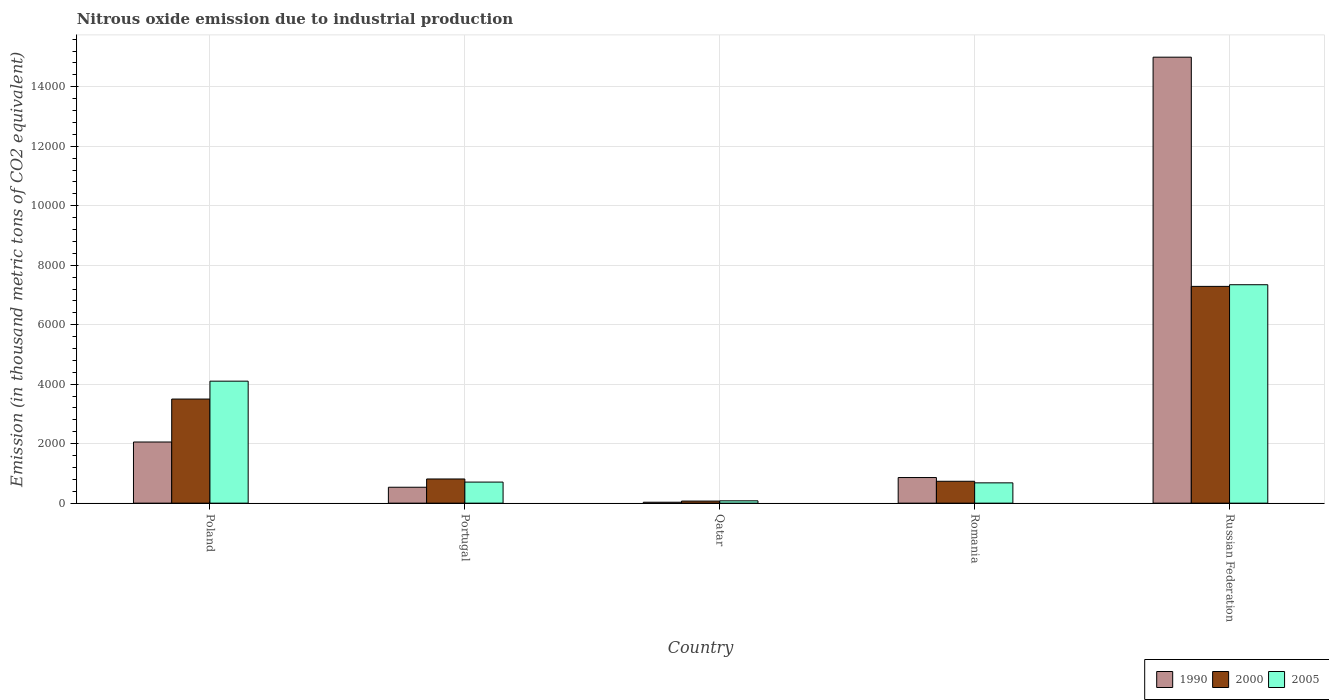How many different coloured bars are there?
Your answer should be very brief. 3. How many groups of bars are there?
Offer a very short reply. 5. How many bars are there on the 2nd tick from the left?
Make the answer very short. 3. What is the label of the 1st group of bars from the left?
Your answer should be very brief. Poland. In how many cases, is the number of bars for a given country not equal to the number of legend labels?
Your response must be concise. 0. What is the amount of nitrous oxide emitted in 1990 in Romania?
Give a very brief answer. 861.1. Across all countries, what is the maximum amount of nitrous oxide emitted in 1990?
Offer a terse response. 1.50e+04. Across all countries, what is the minimum amount of nitrous oxide emitted in 2000?
Provide a succinct answer. 69.5. In which country was the amount of nitrous oxide emitted in 2005 maximum?
Offer a terse response. Russian Federation. In which country was the amount of nitrous oxide emitted in 2005 minimum?
Ensure brevity in your answer.  Qatar. What is the total amount of nitrous oxide emitted in 1990 in the graph?
Make the answer very short. 1.85e+04. What is the difference between the amount of nitrous oxide emitted in 1990 in Portugal and that in Russian Federation?
Keep it short and to the point. -1.45e+04. What is the difference between the amount of nitrous oxide emitted in 2005 in Russian Federation and the amount of nitrous oxide emitted in 1990 in Qatar?
Provide a succinct answer. 7313.3. What is the average amount of nitrous oxide emitted in 2005 per country?
Give a very brief answer. 2582.82. What is the difference between the amount of nitrous oxide emitted of/in 1990 and amount of nitrous oxide emitted of/in 2000 in Romania?
Your answer should be compact. 125.8. What is the ratio of the amount of nitrous oxide emitted in 2000 in Romania to that in Russian Federation?
Your answer should be compact. 0.1. Is the amount of nitrous oxide emitted in 2000 in Romania less than that in Russian Federation?
Keep it short and to the point. Yes. Is the difference between the amount of nitrous oxide emitted in 1990 in Portugal and Romania greater than the difference between the amount of nitrous oxide emitted in 2000 in Portugal and Romania?
Provide a succinct answer. No. What is the difference between the highest and the second highest amount of nitrous oxide emitted in 2005?
Your response must be concise. 6636.1. What is the difference between the highest and the lowest amount of nitrous oxide emitted in 2000?
Your response must be concise. 7218.9. In how many countries, is the amount of nitrous oxide emitted in 1990 greater than the average amount of nitrous oxide emitted in 1990 taken over all countries?
Your answer should be compact. 1. Is the sum of the amount of nitrous oxide emitted in 2005 in Qatar and Russian Federation greater than the maximum amount of nitrous oxide emitted in 2000 across all countries?
Your answer should be compact. Yes. What does the 1st bar from the right in Qatar represents?
Provide a short and direct response. 2005. Is it the case that in every country, the sum of the amount of nitrous oxide emitted in 1990 and amount of nitrous oxide emitted in 2005 is greater than the amount of nitrous oxide emitted in 2000?
Ensure brevity in your answer.  Yes. How many bars are there?
Make the answer very short. 15. How many countries are there in the graph?
Provide a short and direct response. 5. Are the values on the major ticks of Y-axis written in scientific E-notation?
Provide a succinct answer. No. Does the graph contain any zero values?
Give a very brief answer. No. Where does the legend appear in the graph?
Ensure brevity in your answer.  Bottom right. How many legend labels are there?
Your response must be concise. 3. What is the title of the graph?
Offer a terse response. Nitrous oxide emission due to industrial production. What is the label or title of the X-axis?
Keep it short and to the point. Country. What is the label or title of the Y-axis?
Provide a short and direct response. Emission (in thousand metric tons of CO2 equivalent). What is the Emission (in thousand metric tons of CO2 equivalent) in 1990 in Poland?
Your answer should be compact. 2055.6. What is the Emission (in thousand metric tons of CO2 equivalent) in 2000 in Poland?
Your answer should be compact. 3499.7. What is the Emission (in thousand metric tons of CO2 equivalent) of 2005 in Poland?
Ensure brevity in your answer.  4101.5. What is the Emission (in thousand metric tons of CO2 equivalent) in 1990 in Portugal?
Ensure brevity in your answer.  534.9. What is the Emission (in thousand metric tons of CO2 equivalent) in 2000 in Portugal?
Provide a succinct answer. 812.7. What is the Emission (in thousand metric tons of CO2 equivalent) in 2005 in Portugal?
Make the answer very short. 708. What is the Emission (in thousand metric tons of CO2 equivalent) of 1990 in Qatar?
Give a very brief answer. 30.8. What is the Emission (in thousand metric tons of CO2 equivalent) in 2000 in Qatar?
Provide a short and direct response. 69.5. What is the Emission (in thousand metric tons of CO2 equivalent) in 2005 in Qatar?
Offer a very short reply. 78.2. What is the Emission (in thousand metric tons of CO2 equivalent) of 1990 in Romania?
Keep it short and to the point. 861.1. What is the Emission (in thousand metric tons of CO2 equivalent) of 2000 in Romania?
Ensure brevity in your answer.  735.3. What is the Emission (in thousand metric tons of CO2 equivalent) in 2005 in Romania?
Offer a very short reply. 682.3. What is the Emission (in thousand metric tons of CO2 equivalent) of 1990 in Russian Federation?
Offer a terse response. 1.50e+04. What is the Emission (in thousand metric tons of CO2 equivalent) in 2000 in Russian Federation?
Provide a short and direct response. 7288.4. What is the Emission (in thousand metric tons of CO2 equivalent) in 2005 in Russian Federation?
Your answer should be compact. 7344.1. Across all countries, what is the maximum Emission (in thousand metric tons of CO2 equivalent) in 1990?
Offer a terse response. 1.50e+04. Across all countries, what is the maximum Emission (in thousand metric tons of CO2 equivalent) of 2000?
Your answer should be very brief. 7288.4. Across all countries, what is the maximum Emission (in thousand metric tons of CO2 equivalent) in 2005?
Ensure brevity in your answer.  7344.1. Across all countries, what is the minimum Emission (in thousand metric tons of CO2 equivalent) in 1990?
Provide a short and direct response. 30.8. Across all countries, what is the minimum Emission (in thousand metric tons of CO2 equivalent) in 2000?
Your answer should be very brief. 69.5. Across all countries, what is the minimum Emission (in thousand metric tons of CO2 equivalent) in 2005?
Your answer should be very brief. 78.2. What is the total Emission (in thousand metric tons of CO2 equivalent) of 1990 in the graph?
Ensure brevity in your answer.  1.85e+04. What is the total Emission (in thousand metric tons of CO2 equivalent) in 2000 in the graph?
Provide a short and direct response. 1.24e+04. What is the total Emission (in thousand metric tons of CO2 equivalent) of 2005 in the graph?
Make the answer very short. 1.29e+04. What is the difference between the Emission (in thousand metric tons of CO2 equivalent) in 1990 in Poland and that in Portugal?
Offer a very short reply. 1520.7. What is the difference between the Emission (in thousand metric tons of CO2 equivalent) in 2000 in Poland and that in Portugal?
Keep it short and to the point. 2687. What is the difference between the Emission (in thousand metric tons of CO2 equivalent) in 2005 in Poland and that in Portugal?
Ensure brevity in your answer.  3393.5. What is the difference between the Emission (in thousand metric tons of CO2 equivalent) in 1990 in Poland and that in Qatar?
Make the answer very short. 2024.8. What is the difference between the Emission (in thousand metric tons of CO2 equivalent) of 2000 in Poland and that in Qatar?
Make the answer very short. 3430.2. What is the difference between the Emission (in thousand metric tons of CO2 equivalent) in 2005 in Poland and that in Qatar?
Offer a very short reply. 4023.3. What is the difference between the Emission (in thousand metric tons of CO2 equivalent) of 1990 in Poland and that in Romania?
Your response must be concise. 1194.5. What is the difference between the Emission (in thousand metric tons of CO2 equivalent) in 2000 in Poland and that in Romania?
Your response must be concise. 2764.4. What is the difference between the Emission (in thousand metric tons of CO2 equivalent) of 2005 in Poland and that in Romania?
Your answer should be very brief. 3419.2. What is the difference between the Emission (in thousand metric tons of CO2 equivalent) of 1990 in Poland and that in Russian Federation?
Your answer should be very brief. -1.29e+04. What is the difference between the Emission (in thousand metric tons of CO2 equivalent) of 2000 in Poland and that in Russian Federation?
Offer a terse response. -3788.7. What is the difference between the Emission (in thousand metric tons of CO2 equivalent) of 2005 in Poland and that in Russian Federation?
Offer a very short reply. -3242.6. What is the difference between the Emission (in thousand metric tons of CO2 equivalent) of 1990 in Portugal and that in Qatar?
Offer a very short reply. 504.1. What is the difference between the Emission (in thousand metric tons of CO2 equivalent) of 2000 in Portugal and that in Qatar?
Your response must be concise. 743.2. What is the difference between the Emission (in thousand metric tons of CO2 equivalent) in 2005 in Portugal and that in Qatar?
Offer a very short reply. 629.8. What is the difference between the Emission (in thousand metric tons of CO2 equivalent) in 1990 in Portugal and that in Romania?
Give a very brief answer. -326.2. What is the difference between the Emission (in thousand metric tons of CO2 equivalent) of 2000 in Portugal and that in Romania?
Offer a terse response. 77.4. What is the difference between the Emission (in thousand metric tons of CO2 equivalent) in 2005 in Portugal and that in Romania?
Offer a terse response. 25.7. What is the difference between the Emission (in thousand metric tons of CO2 equivalent) of 1990 in Portugal and that in Russian Federation?
Offer a terse response. -1.45e+04. What is the difference between the Emission (in thousand metric tons of CO2 equivalent) in 2000 in Portugal and that in Russian Federation?
Give a very brief answer. -6475.7. What is the difference between the Emission (in thousand metric tons of CO2 equivalent) in 2005 in Portugal and that in Russian Federation?
Your answer should be compact. -6636.1. What is the difference between the Emission (in thousand metric tons of CO2 equivalent) in 1990 in Qatar and that in Romania?
Give a very brief answer. -830.3. What is the difference between the Emission (in thousand metric tons of CO2 equivalent) in 2000 in Qatar and that in Romania?
Offer a very short reply. -665.8. What is the difference between the Emission (in thousand metric tons of CO2 equivalent) of 2005 in Qatar and that in Romania?
Your answer should be compact. -604.1. What is the difference between the Emission (in thousand metric tons of CO2 equivalent) in 1990 in Qatar and that in Russian Federation?
Keep it short and to the point. -1.50e+04. What is the difference between the Emission (in thousand metric tons of CO2 equivalent) in 2000 in Qatar and that in Russian Federation?
Give a very brief answer. -7218.9. What is the difference between the Emission (in thousand metric tons of CO2 equivalent) of 2005 in Qatar and that in Russian Federation?
Your answer should be compact. -7265.9. What is the difference between the Emission (in thousand metric tons of CO2 equivalent) of 1990 in Romania and that in Russian Federation?
Offer a terse response. -1.41e+04. What is the difference between the Emission (in thousand metric tons of CO2 equivalent) in 2000 in Romania and that in Russian Federation?
Provide a short and direct response. -6553.1. What is the difference between the Emission (in thousand metric tons of CO2 equivalent) in 2005 in Romania and that in Russian Federation?
Give a very brief answer. -6661.8. What is the difference between the Emission (in thousand metric tons of CO2 equivalent) of 1990 in Poland and the Emission (in thousand metric tons of CO2 equivalent) of 2000 in Portugal?
Your response must be concise. 1242.9. What is the difference between the Emission (in thousand metric tons of CO2 equivalent) of 1990 in Poland and the Emission (in thousand metric tons of CO2 equivalent) of 2005 in Portugal?
Give a very brief answer. 1347.6. What is the difference between the Emission (in thousand metric tons of CO2 equivalent) in 2000 in Poland and the Emission (in thousand metric tons of CO2 equivalent) in 2005 in Portugal?
Your answer should be compact. 2791.7. What is the difference between the Emission (in thousand metric tons of CO2 equivalent) in 1990 in Poland and the Emission (in thousand metric tons of CO2 equivalent) in 2000 in Qatar?
Give a very brief answer. 1986.1. What is the difference between the Emission (in thousand metric tons of CO2 equivalent) of 1990 in Poland and the Emission (in thousand metric tons of CO2 equivalent) of 2005 in Qatar?
Give a very brief answer. 1977.4. What is the difference between the Emission (in thousand metric tons of CO2 equivalent) of 2000 in Poland and the Emission (in thousand metric tons of CO2 equivalent) of 2005 in Qatar?
Make the answer very short. 3421.5. What is the difference between the Emission (in thousand metric tons of CO2 equivalent) in 1990 in Poland and the Emission (in thousand metric tons of CO2 equivalent) in 2000 in Romania?
Give a very brief answer. 1320.3. What is the difference between the Emission (in thousand metric tons of CO2 equivalent) in 1990 in Poland and the Emission (in thousand metric tons of CO2 equivalent) in 2005 in Romania?
Your response must be concise. 1373.3. What is the difference between the Emission (in thousand metric tons of CO2 equivalent) in 2000 in Poland and the Emission (in thousand metric tons of CO2 equivalent) in 2005 in Romania?
Your answer should be compact. 2817.4. What is the difference between the Emission (in thousand metric tons of CO2 equivalent) in 1990 in Poland and the Emission (in thousand metric tons of CO2 equivalent) in 2000 in Russian Federation?
Ensure brevity in your answer.  -5232.8. What is the difference between the Emission (in thousand metric tons of CO2 equivalent) of 1990 in Poland and the Emission (in thousand metric tons of CO2 equivalent) of 2005 in Russian Federation?
Keep it short and to the point. -5288.5. What is the difference between the Emission (in thousand metric tons of CO2 equivalent) of 2000 in Poland and the Emission (in thousand metric tons of CO2 equivalent) of 2005 in Russian Federation?
Offer a terse response. -3844.4. What is the difference between the Emission (in thousand metric tons of CO2 equivalent) of 1990 in Portugal and the Emission (in thousand metric tons of CO2 equivalent) of 2000 in Qatar?
Make the answer very short. 465.4. What is the difference between the Emission (in thousand metric tons of CO2 equivalent) in 1990 in Portugal and the Emission (in thousand metric tons of CO2 equivalent) in 2005 in Qatar?
Provide a succinct answer. 456.7. What is the difference between the Emission (in thousand metric tons of CO2 equivalent) of 2000 in Portugal and the Emission (in thousand metric tons of CO2 equivalent) of 2005 in Qatar?
Keep it short and to the point. 734.5. What is the difference between the Emission (in thousand metric tons of CO2 equivalent) in 1990 in Portugal and the Emission (in thousand metric tons of CO2 equivalent) in 2000 in Romania?
Make the answer very short. -200.4. What is the difference between the Emission (in thousand metric tons of CO2 equivalent) of 1990 in Portugal and the Emission (in thousand metric tons of CO2 equivalent) of 2005 in Romania?
Provide a succinct answer. -147.4. What is the difference between the Emission (in thousand metric tons of CO2 equivalent) in 2000 in Portugal and the Emission (in thousand metric tons of CO2 equivalent) in 2005 in Romania?
Keep it short and to the point. 130.4. What is the difference between the Emission (in thousand metric tons of CO2 equivalent) in 1990 in Portugal and the Emission (in thousand metric tons of CO2 equivalent) in 2000 in Russian Federation?
Provide a short and direct response. -6753.5. What is the difference between the Emission (in thousand metric tons of CO2 equivalent) in 1990 in Portugal and the Emission (in thousand metric tons of CO2 equivalent) in 2005 in Russian Federation?
Offer a terse response. -6809.2. What is the difference between the Emission (in thousand metric tons of CO2 equivalent) of 2000 in Portugal and the Emission (in thousand metric tons of CO2 equivalent) of 2005 in Russian Federation?
Provide a succinct answer. -6531.4. What is the difference between the Emission (in thousand metric tons of CO2 equivalent) in 1990 in Qatar and the Emission (in thousand metric tons of CO2 equivalent) in 2000 in Romania?
Ensure brevity in your answer.  -704.5. What is the difference between the Emission (in thousand metric tons of CO2 equivalent) in 1990 in Qatar and the Emission (in thousand metric tons of CO2 equivalent) in 2005 in Romania?
Give a very brief answer. -651.5. What is the difference between the Emission (in thousand metric tons of CO2 equivalent) in 2000 in Qatar and the Emission (in thousand metric tons of CO2 equivalent) in 2005 in Romania?
Offer a very short reply. -612.8. What is the difference between the Emission (in thousand metric tons of CO2 equivalent) in 1990 in Qatar and the Emission (in thousand metric tons of CO2 equivalent) in 2000 in Russian Federation?
Your response must be concise. -7257.6. What is the difference between the Emission (in thousand metric tons of CO2 equivalent) in 1990 in Qatar and the Emission (in thousand metric tons of CO2 equivalent) in 2005 in Russian Federation?
Keep it short and to the point. -7313.3. What is the difference between the Emission (in thousand metric tons of CO2 equivalent) of 2000 in Qatar and the Emission (in thousand metric tons of CO2 equivalent) of 2005 in Russian Federation?
Keep it short and to the point. -7274.6. What is the difference between the Emission (in thousand metric tons of CO2 equivalent) in 1990 in Romania and the Emission (in thousand metric tons of CO2 equivalent) in 2000 in Russian Federation?
Your answer should be very brief. -6427.3. What is the difference between the Emission (in thousand metric tons of CO2 equivalent) in 1990 in Romania and the Emission (in thousand metric tons of CO2 equivalent) in 2005 in Russian Federation?
Provide a succinct answer. -6483. What is the difference between the Emission (in thousand metric tons of CO2 equivalent) of 2000 in Romania and the Emission (in thousand metric tons of CO2 equivalent) of 2005 in Russian Federation?
Provide a short and direct response. -6608.8. What is the average Emission (in thousand metric tons of CO2 equivalent) of 1990 per country?
Offer a very short reply. 3695.54. What is the average Emission (in thousand metric tons of CO2 equivalent) in 2000 per country?
Your answer should be very brief. 2481.12. What is the average Emission (in thousand metric tons of CO2 equivalent) in 2005 per country?
Make the answer very short. 2582.82. What is the difference between the Emission (in thousand metric tons of CO2 equivalent) in 1990 and Emission (in thousand metric tons of CO2 equivalent) in 2000 in Poland?
Keep it short and to the point. -1444.1. What is the difference between the Emission (in thousand metric tons of CO2 equivalent) in 1990 and Emission (in thousand metric tons of CO2 equivalent) in 2005 in Poland?
Offer a very short reply. -2045.9. What is the difference between the Emission (in thousand metric tons of CO2 equivalent) of 2000 and Emission (in thousand metric tons of CO2 equivalent) of 2005 in Poland?
Your answer should be compact. -601.8. What is the difference between the Emission (in thousand metric tons of CO2 equivalent) of 1990 and Emission (in thousand metric tons of CO2 equivalent) of 2000 in Portugal?
Make the answer very short. -277.8. What is the difference between the Emission (in thousand metric tons of CO2 equivalent) of 1990 and Emission (in thousand metric tons of CO2 equivalent) of 2005 in Portugal?
Keep it short and to the point. -173.1. What is the difference between the Emission (in thousand metric tons of CO2 equivalent) of 2000 and Emission (in thousand metric tons of CO2 equivalent) of 2005 in Portugal?
Make the answer very short. 104.7. What is the difference between the Emission (in thousand metric tons of CO2 equivalent) in 1990 and Emission (in thousand metric tons of CO2 equivalent) in 2000 in Qatar?
Your answer should be very brief. -38.7. What is the difference between the Emission (in thousand metric tons of CO2 equivalent) in 1990 and Emission (in thousand metric tons of CO2 equivalent) in 2005 in Qatar?
Your answer should be compact. -47.4. What is the difference between the Emission (in thousand metric tons of CO2 equivalent) of 1990 and Emission (in thousand metric tons of CO2 equivalent) of 2000 in Romania?
Make the answer very short. 125.8. What is the difference between the Emission (in thousand metric tons of CO2 equivalent) in 1990 and Emission (in thousand metric tons of CO2 equivalent) in 2005 in Romania?
Offer a very short reply. 178.8. What is the difference between the Emission (in thousand metric tons of CO2 equivalent) of 2000 and Emission (in thousand metric tons of CO2 equivalent) of 2005 in Romania?
Make the answer very short. 53. What is the difference between the Emission (in thousand metric tons of CO2 equivalent) of 1990 and Emission (in thousand metric tons of CO2 equivalent) of 2000 in Russian Federation?
Provide a short and direct response. 7706.9. What is the difference between the Emission (in thousand metric tons of CO2 equivalent) of 1990 and Emission (in thousand metric tons of CO2 equivalent) of 2005 in Russian Federation?
Your answer should be very brief. 7651.2. What is the difference between the Emission (in thousand metric tons of CO2 equivalent) in 2000 and Emission (in thousand metric tons of CO2 equivalent) in 2005 in Russian Federation?
Your answer should be compact. -55.7. What is the ratio of the Emission (in thousand metric tons of CO2 equivalent) in 1990 in Poland to that in Portugal?
Provide a succinct answer. 3.84. What is the ratio of the Emission (in thousand metric tons of CO2 equivalent) in 2000 in Poland to that in Portugal?
Offer a terse response. 4.31. What is the ratio of the Emission (in thousand metric tons of CO2 equivalent) of 2005 in Poland to that in Portugal?
Ensure brevity in your answer.  5.79. What is the ratio of the Emission (in thousand metric tons of CO2 equivalent) of 1990 in Poland to that in Qatar?
Your response must be concise. 66.74. What is the ratio of the Emission (in thousand metric tons of CO2 equivalent) in 2000 in Poland to that in Qatar?
Make the answer very short. 50.36. What is the ratio of the Emission (in thousand metric tons of CO2 equivalent) in 2005 in Poland to that in Qatar?
Keep it short and to the point. 52.45. What is the ratio of the Emission (in thousand metric tons of CO2 equivalent) in 1990 in Poland to that in Romania?
Give a very brief answer. 2.39. What is the ratio of the Emission (in thousand metric tons of CO2 equivalent) of 2000 in Poland to that in Romania?
Offer a very short reply. 4.76. What is the ratio of the Emission (in thousand metric tons of CO2 equivalent) of 2005 in Poland to that in Romania?
Your response must be concise. 6.01. What is the ratio of the Emission (in thousand metric tons of CO2 equivalent) of 1990 in Poland to that in Russian Federation?
Provide a short and direct response. 0.14. What is the ratio of the Emission (in thousand metric tons of CO2 equivalent) of 2000 in Poland to that in Russian Federation?
Your answer should be compact. 0.48. What is the ratio of the Emission (in thousand metric tons of CO2 equivalent) of 2005 in Poland to that in Russian Federation?
Keep it short and to the point. 0.56. What is the ratio of the Emission (in thousand metric tons of CO2 equivalent) of 1990 in Portugal to that in Qatar?
Provide a short and direct response. 17.37. What is the ratio of the Emission (in thousand metric tons of CO2 equivalent) in 2000 in Portugal to that in Qatar?
Your answer should be very brief. 11.69. What is the ratio of the Emission (in thousand metric tons of CO2 equivalent) in 2005 in Portugal to that in Qatar?
Provide a short and direct response. 9.05. What is the ratio of the Emission (in thousand metric tons of CO2 equivalent) in 1990 in Portugal to that in Romania?
Provide a succinct answer. 0.62. What is the ratio of the Emission (in thousand metric tons of CO2 equivalent) in 2000 in Portugal to that in Romania?
Ensure brevity in your answer.  1.11. What is the ratio of the Emission (in thousand metric tons of CO2 equivalent) of 2005 in Portugal to that in Romania?
Your response must be concise. 1.04. What is the ratio of the Emission (in thousand metric tons of CO2 equivalent) of 1990 in Portugal to that in Russian Federation?
Make the answer very short. 0.04. What is the ratio of the Emission (in thousand metric tons of CO2 equivalent) in 2000 in Portugal to that in Russian Federation?
Provide a short and direct response. 0.11. What is the ratio of the Emission (in thousand metric tons of CO2 equivalent) in 2005 in Portugal to that in Russian Federation?
Your response must be concise. 0.1. What is the ratio of the Emission (in thousand metric tons of CO2 equivalent) of 1990 in Qatar to that in Romania?
Keep it short and to the point. 0.04. What is the ratio of the Emission (in thousand metric tons of CO2 equivalent) of 2000 in Qatar to that in Romania?
Keep it short and to the point. 0.09. What is the ratio of the Emission (in thousand metric tons of CO2 equivalent) of 2005 in Qatar to that in Romania?
Provide a short and direct response. 0.11. What is the ratio of the Emission (in thousand metric tons of CO2 equivalent) in 1990 in Qatar to that in Russian Federation?
Give a very brief answer. 0. What is the ratio of the Emission (in thousand metric tons of CO2 equivalent) in 2000 in Qatar to that in Russian Federation?
Provide a short and direct response. 0.01. What is the ratio of the Emission (in thousand metric tons of CO2 equivalent) in 2005 in Qatar to that in Russian Federation?
Ensure brevity in your answer.  0.01. What is the ratio of the Emission (in thousand metric tons of CO2 equivalent) in 1990 in Romania to that in Russian Federation?
Give a very brief answer. 0.06. What is the ratio of the Emission (in thousand metric tons of CO2 equivalent) in 2000 in Romania to that in Russian Federation?
Offer a very short reply. 0.1. What is the ratio of the Emission (in thousand metric tons of CO2 equivalent) in 2005 in Romania to that in Russian Federation?
Your answer should be compact. 0.09. What is the difference between the highest and the second highest Emission (in thousand metric tons of CO2 equivalent) of 1990?
Keep it short and to the point. 1.29e+04. What is the difference between the highest and the second highest Emission (in thousand metric tons of CO2 equivalent) in 2000?
Keep it short and to the point. 3788.7. What is the difference between the highest and the second highest Emission (in thousand metric tons of CO2 equivalent) of 2005?
Offer a terse response. 3242.6. What is the difference between the highest and the lowest Emission (in thousand metric tons of CO2 equivalent) in 1990?
Your answer should be very brief. 1.50e+04. What is the difference between the highest and the lowest Emission (in thousand metric tons of CO2 equivalent) of 2000?
Ensure brevity in your answer.  7218.9. What is the difference between the highest and the lowest Emission (in thousand metric tons of CO2 equivalent) in 2005?
Ensure brevity in your answer.  7265.9. 